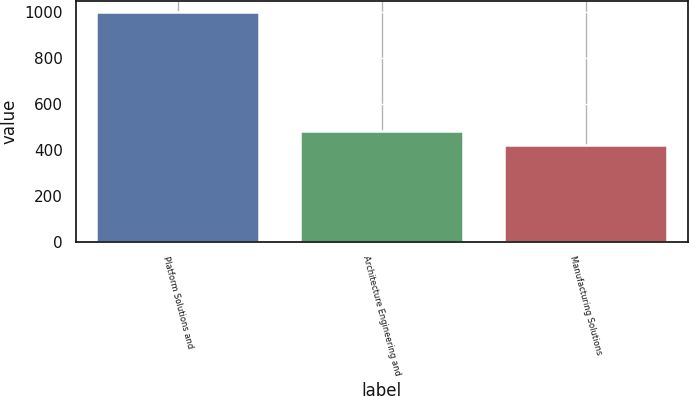Convert chart to OTSL. <chart><loc_0><loc_0><loc_500><loc_500><bar_chart><fcel>Platform Solutions and<fcel>Architecture Engineering and<fcel>Manufacturing Solutions<nl><fcel>997.1<fcel>480<fcel>418<nl></chart> 